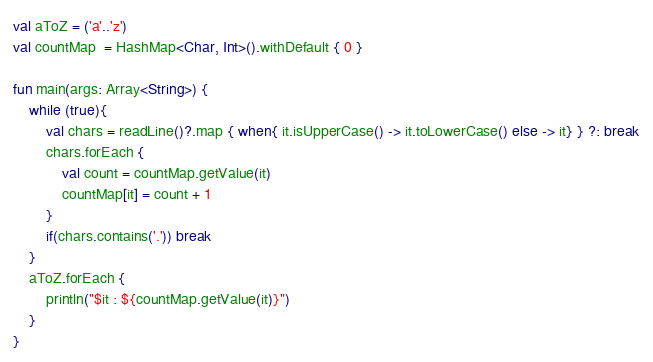Convert code to text. <code><loc_0><loc_0><loc_500><loc_500><_Kotlin_>val aToZ = ('a'..'z')
val countMap  = HashMap<Char, Int>().withDefault { 0 }

fun main(args: Array<String>) {
    while (true){
        val chars = readLine()?.map { when{ it.isUpperCase() -> it.toLowerCase() else -> it} } ?: break
        chars.forEach {
            val count = countMap.getValue(it)
            countMap[it] = count + 1
        }
        if(chars.contains('.')) break
    }
    aToZ.forEach {
        println("$it : ${countMap.getValue(it)}")
    }
}
</code> 